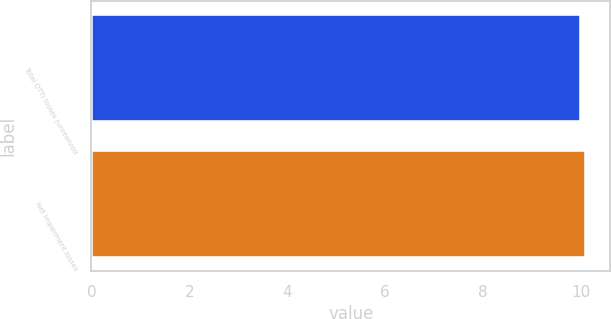Convert chart to OTSL. <chart><loc_0><loc_0><loc_500><loc_500><bar_chart><fcel>Total OTTI losses (unrealized<fcel>Net impairment losses<nl><fcel>10<fcel>10.1<nl></chart> 